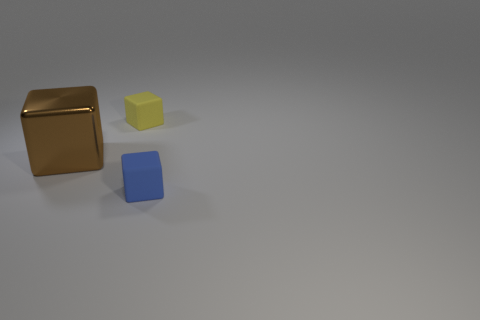Add 3 small cyan metallic cylinders. How many objects exist? 6 Subtract all small blue rubber blocks. Subtract all brown things. How many objects are left? 1 Add 3 large brown shiny things. How many large brown shiny things are left? 4 Add 1 large shiny blocks. How many large shiny blocks exist? 2 Subtract 0 blue cylinders. How many objects are left? 3 